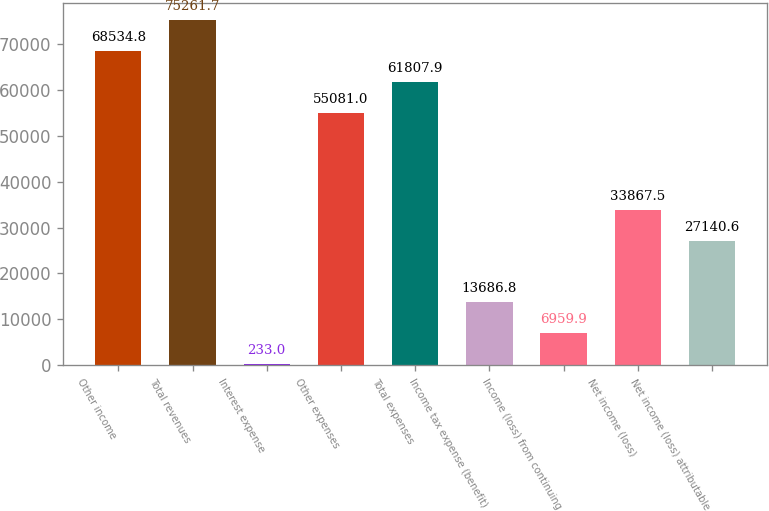Convert chart. <chart><loc_0><loc_0><loc_500><loc_500><bar_chart><fcel>Other income<fcel>Total revenues<fcel>Interest expense<fcel>Other expenses<fcel>Total expenses<fcel>Income tax expense (benefit)<fcel>Income (loss) from continuing<fcel>Net income (loss)<fcel>Net income (loss) attributable<nl><fcel>68534.8<fcel>75261.7<fcel>233<fcel>55081<fcel>61807.9<fcel>13686.8<fcel>6959.9<fcel>33867.5<fcel>27140.6<nl></chart> 